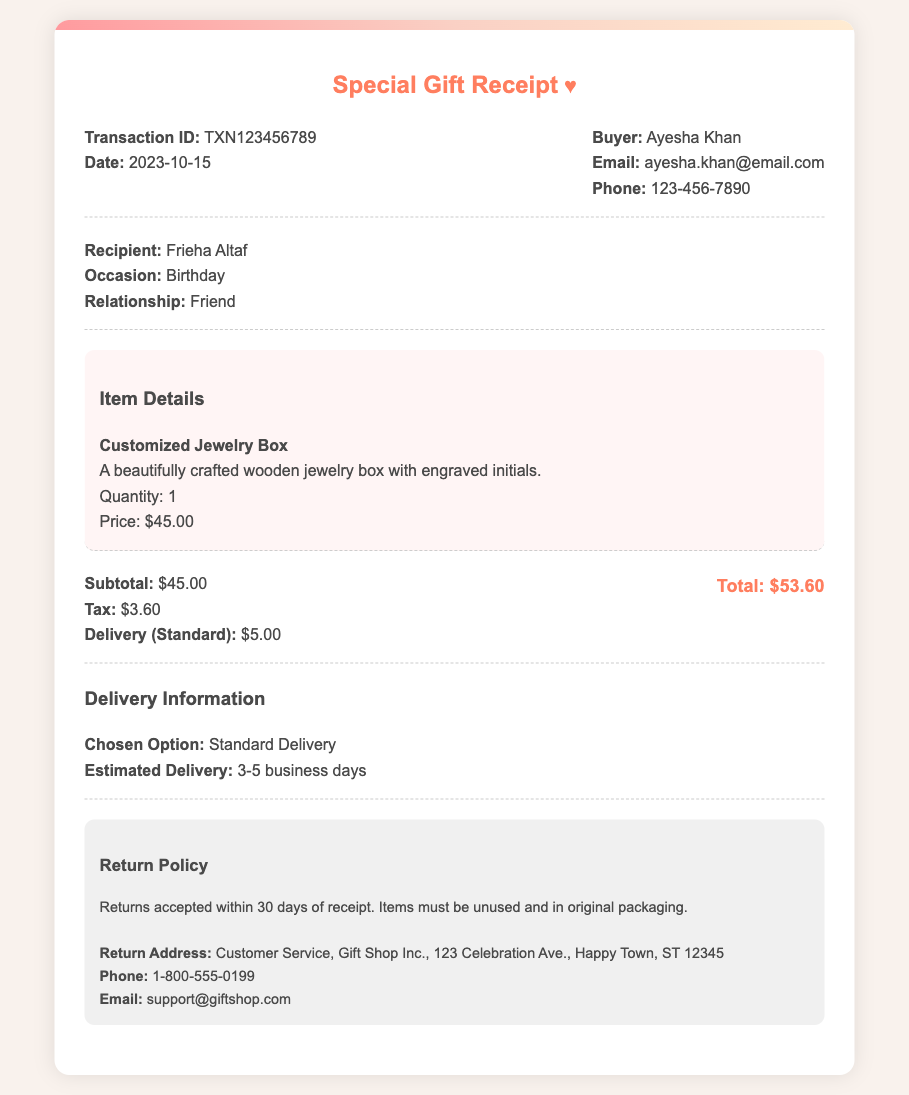What is the transaction ID? The transaction ID is a unique identifier for the transaction provided in the document.
Answer: TXN123456789 What is the total amount? The total amount is the sum of the subtotal, tax, and delivery charge, shown at the bottom of the receipt.
Answer: $53.60 What is the estimated delivery time? The estimated delivery time is indicated in the delivery information section of the document.
Answer: 3-5 business days Who is the recipient of the gift? The recipient of the gift is mentioned in the section that specifies the occasion and relationship.
Answer: Frieha Altaf What is the return policy timeframe? The return policy timeframe is indicated, specifying how long returns are accepted after receipt.
Answer: 30 days 